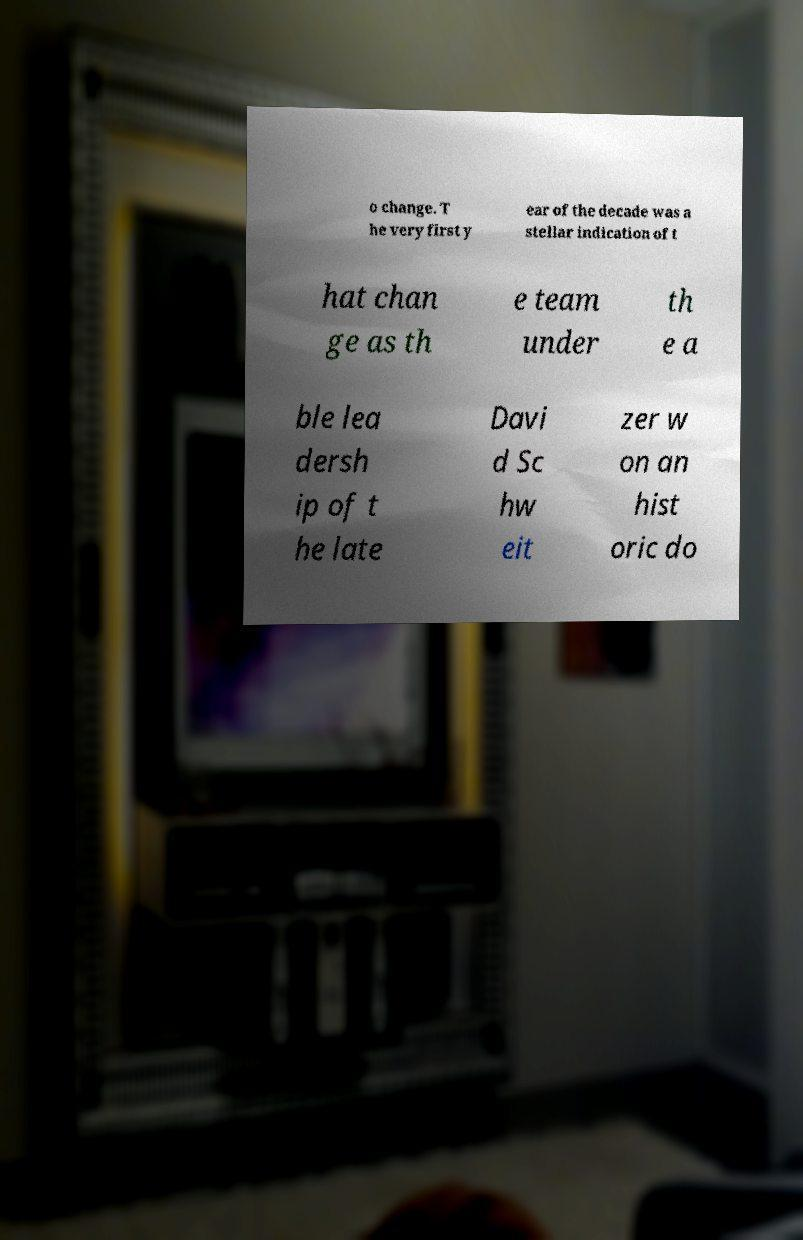Could you extract and type out the text from this image? o change. T he very first y ear of the decade was a stellar indication of t hat chan ge as th e team under th e a ble lea dersh ip of t he late Davi d Sc hw eit zer w on an hist oric do 